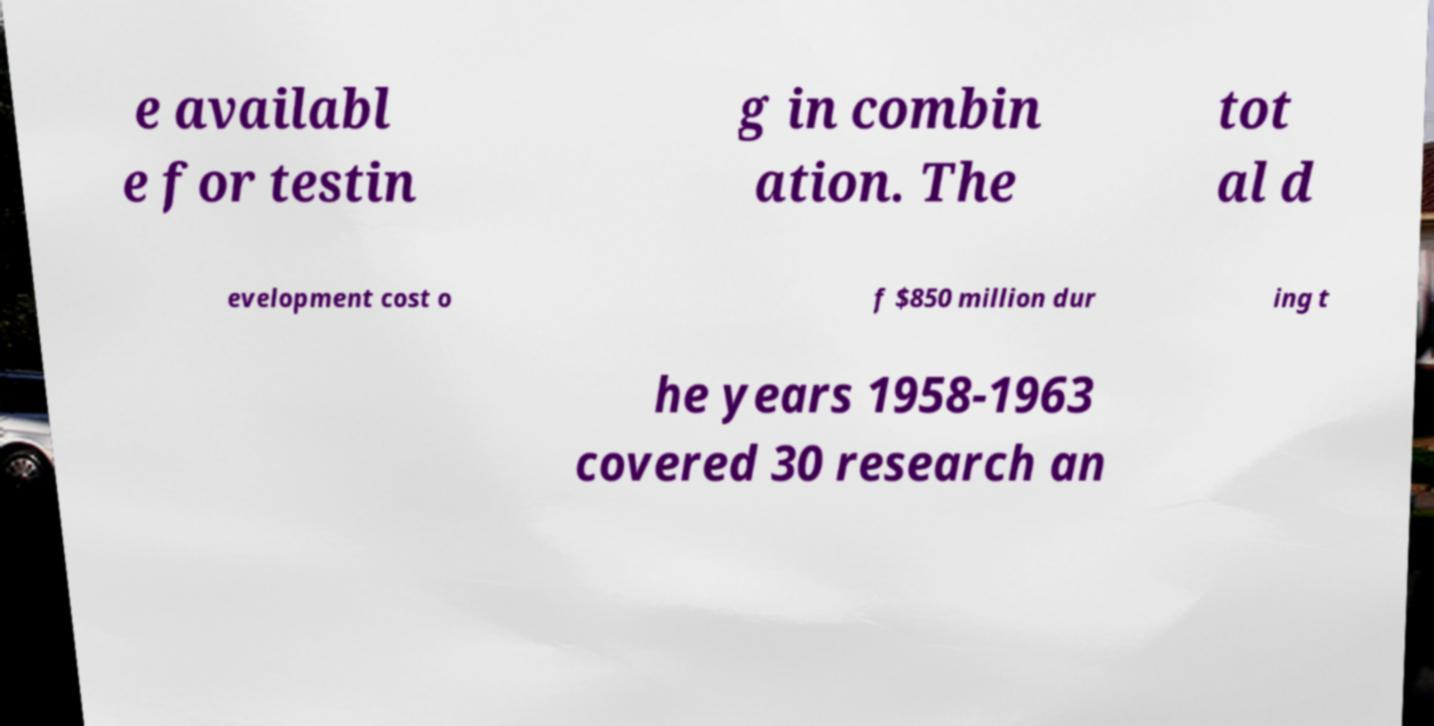There's text embedded in this image that I need extracted. Can you transcribe it verbatim? e availabl e for testin g in combin ation. The tot al d evelopment cost o f $850 million dur ing t he years 1958-1963 covered 30 research an 